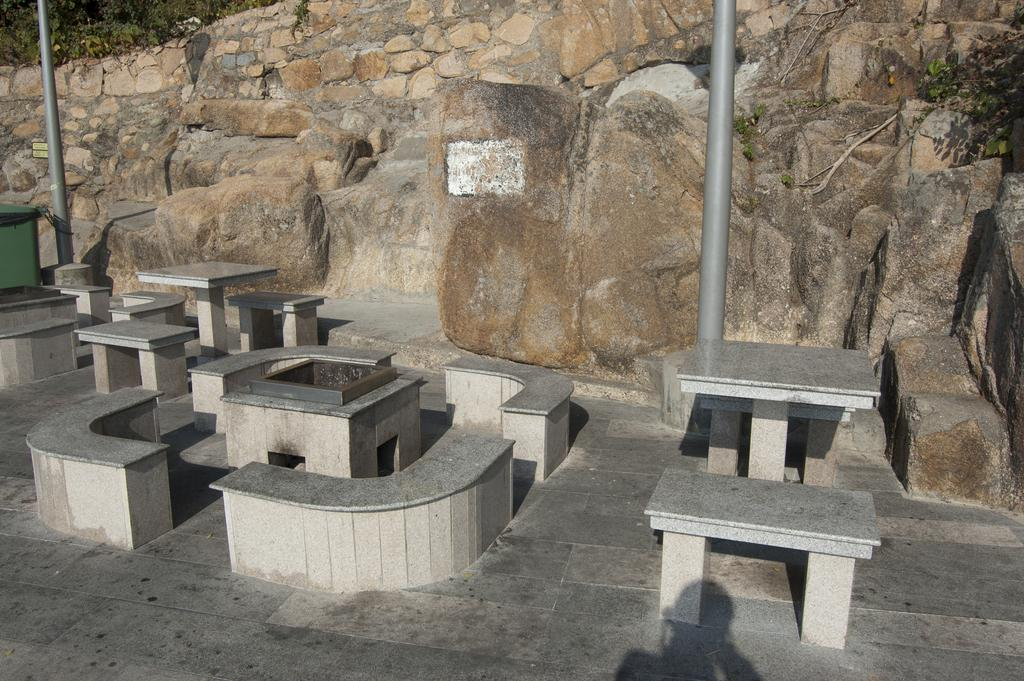What type of seating is available in the image? There are concrete benches in the image. What can be used for placing objects or eating in the image? There are concrete tables in the image. What structures are located behind the benches? There are two poles behind the benches. What natural elements are present in the image? Rocks and trees are visible in the image. Can you see a bee using a quill to write on a wound in the image? No, there is no bee, quill, or wound present in the image. 